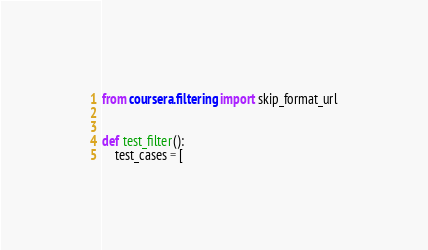Convert code to text. <code><loc_0><loc_0><loc_500><loc_500><_Python_>from coursera.filtering import skip_format_url


def test_filter():
    test_cases = [</code> 